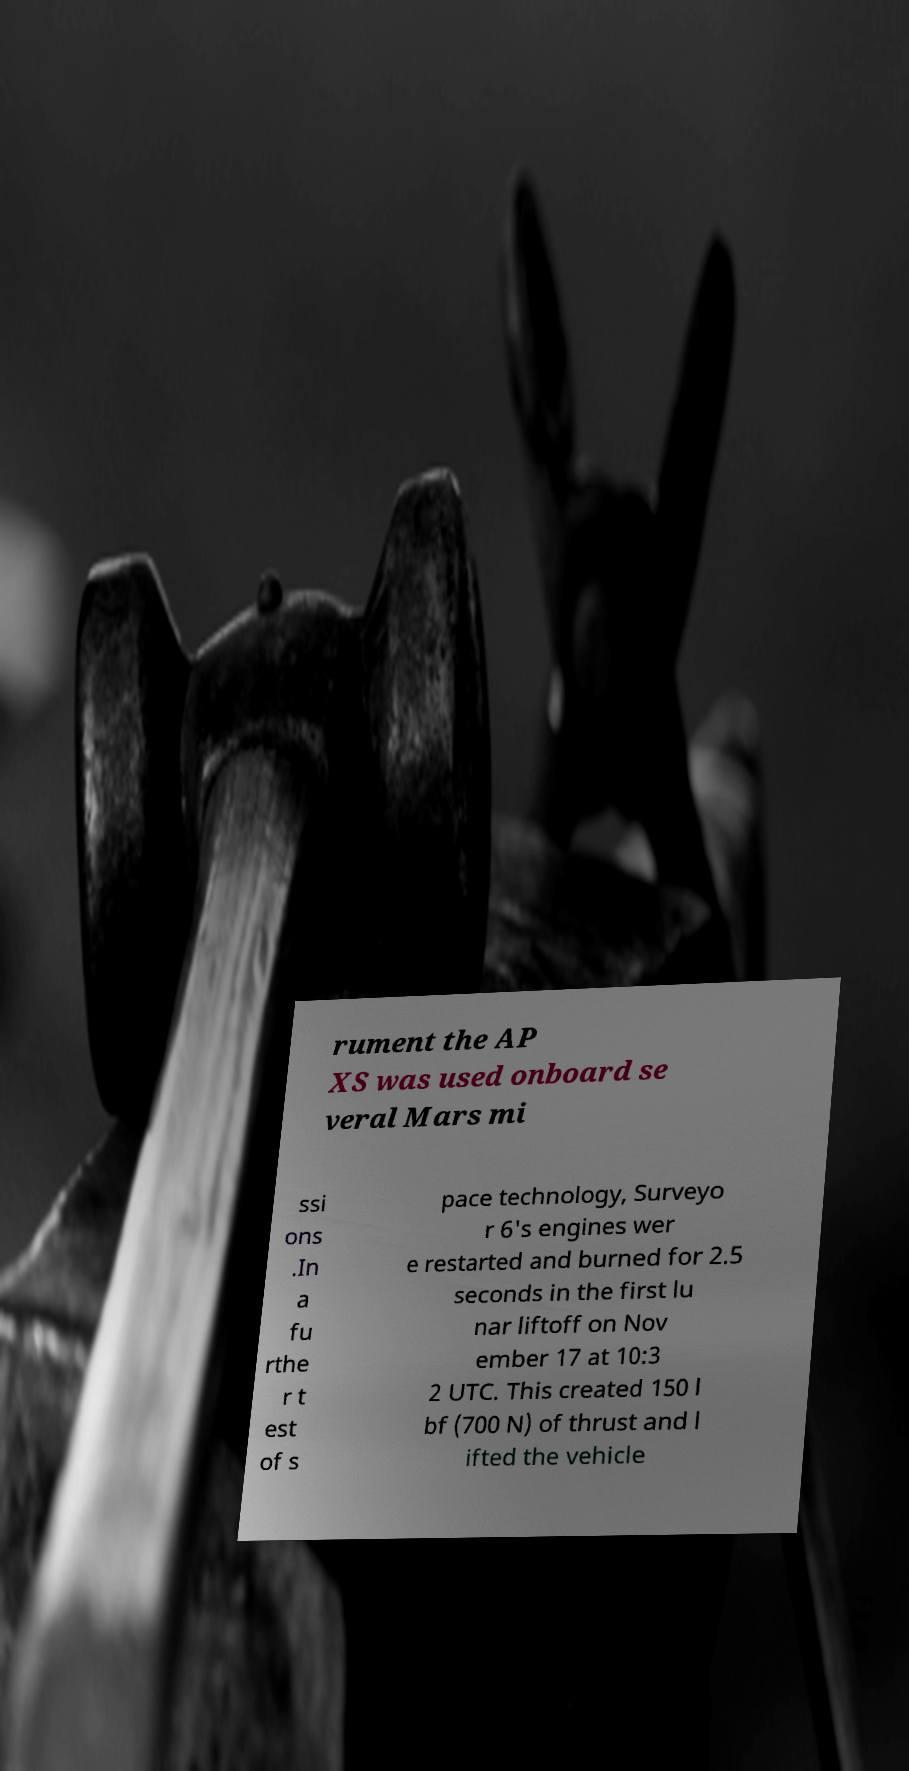There's text embedded in this image that I need extracted. Can you transcribe it verbatim? rument the AP XS was used onboard se veral Mars mi ssi ons .In a fu rthe r t est of s pace technology, Surveyo r 6's engines wer e restarted and burned for 2.5 seconds in the first lu nar liftoff on Nov ember 17 at 10:3 2 UTC. This created 150 l bf (700 N) of thrust and l ifted the vehicle 